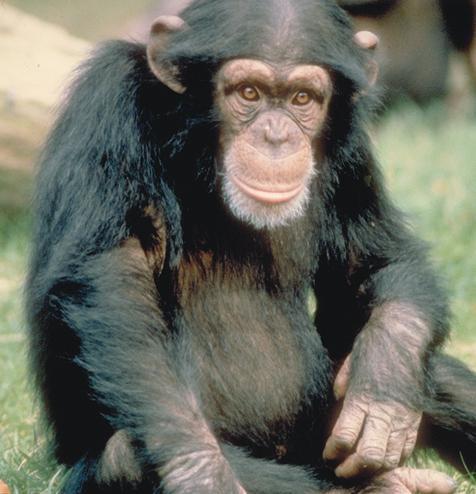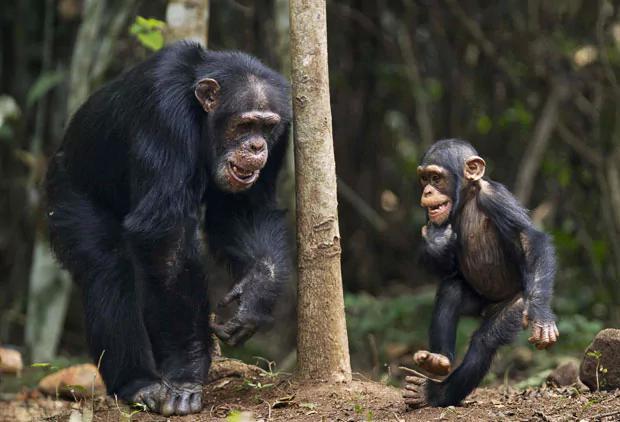The first image is the image on the left, the second image is the image on the right. Analyze the images presented: Is the assertion "There are four monkey-type animals including very young ones." valid? Answer yes or no. No. 